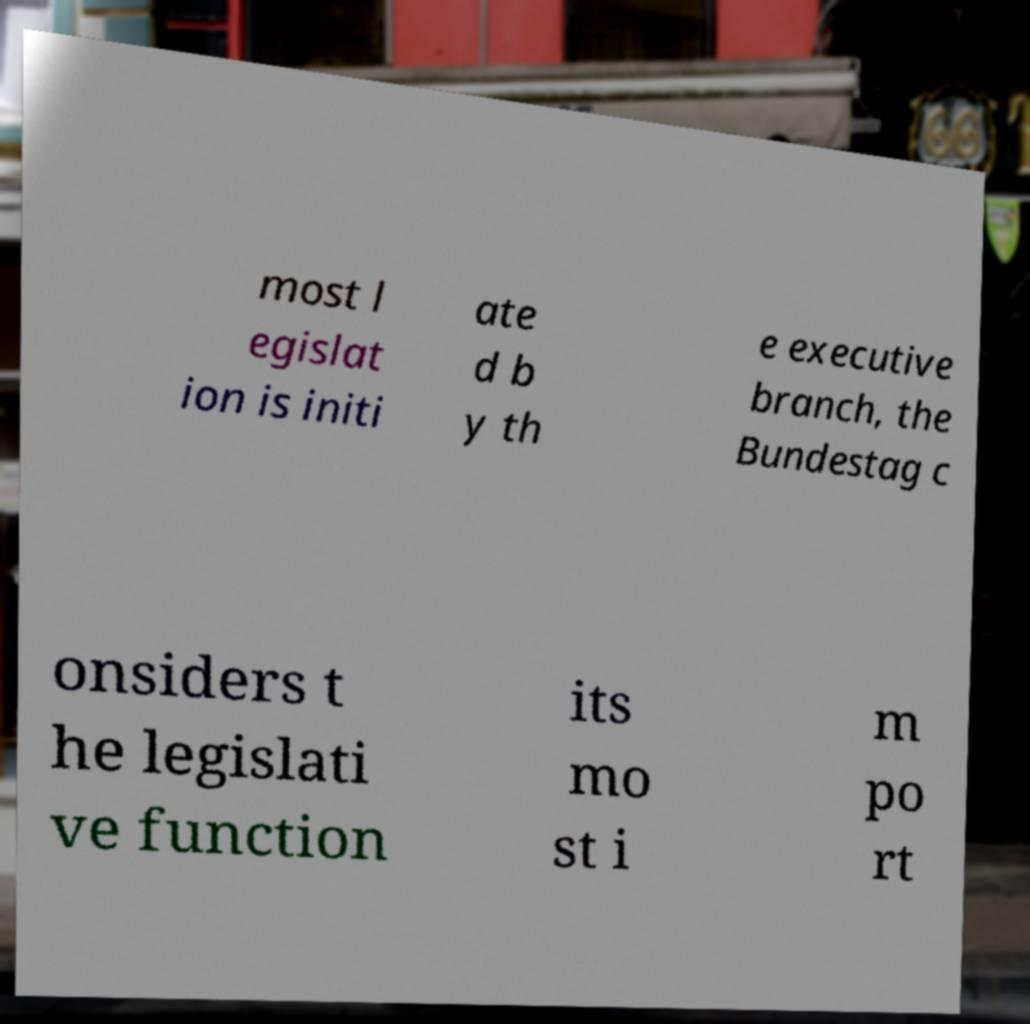For documentation purposes, I need the text within this image transcribed. Could you provide that? most l egislat ion is initi ate d b y th e executive branch, the Bundestag c onsiders t he legislati ve function its mo st i m po rt 